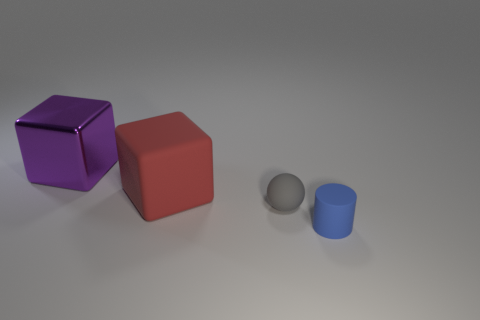Are there the same number of red blocks behind the large purple metallic object and red rubber cubes that are on the right side of the large matte cube? Yes, the number of red blocks behind the large purple metallic cube is the same as the number of small red rubber cubes situated to the right of the large matte cube. Specifically, there is one red block of each kind. 